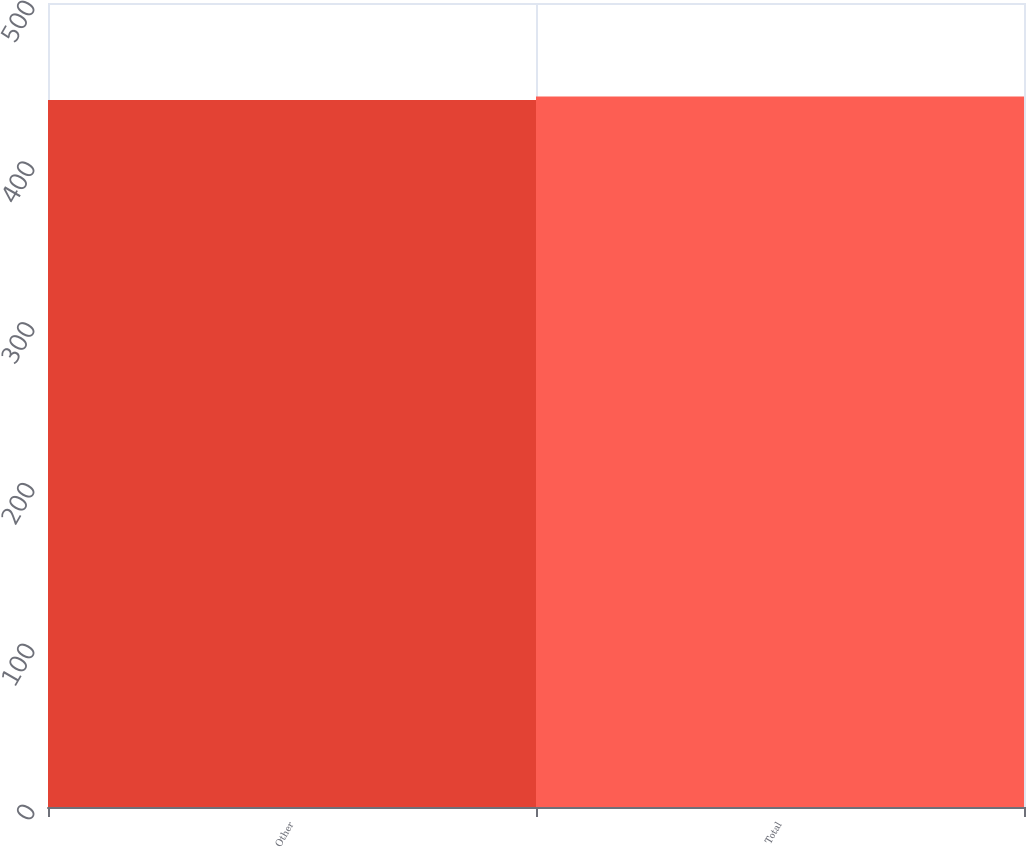Convert chart. <chart><loc_0><loc_0><loc_500><loc_500><bar_chart><fcel>Other<fcel>Total<nl><fcel>439.6<fcel>441.9<nl></chart> 